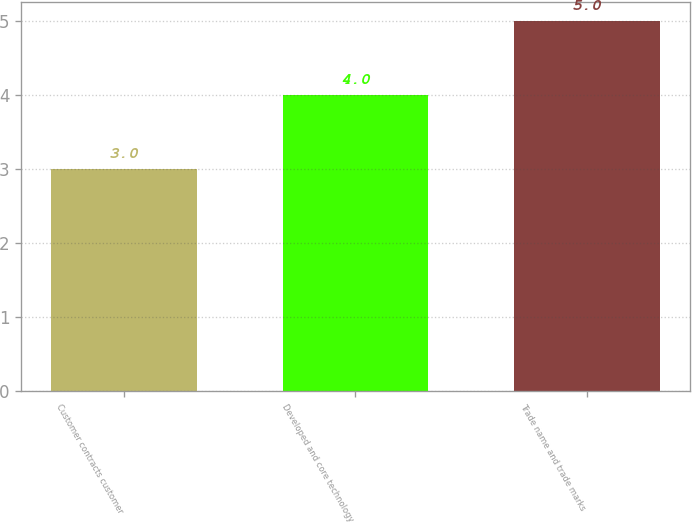Convert chart. <chart><loc_0><loc_0><loc_500><loc_500><bar_chart><fcel>Customer contracts customer<fcel>Developed and core technology<fcel>Trade name and trade marks<nl><fcel>3<fcel>4<fcel>5<nl></chart> 